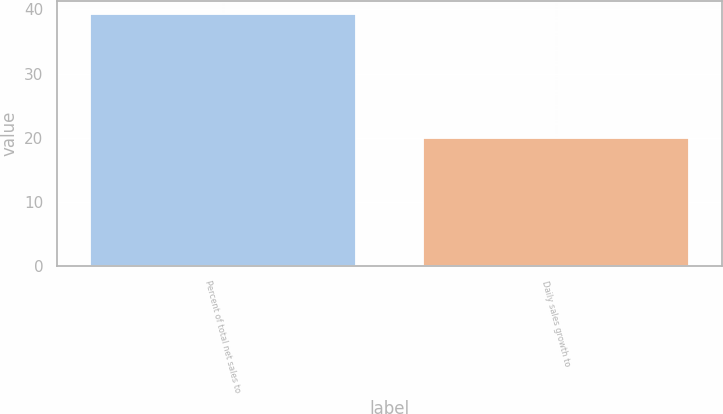Convert chart. <chart><loc_0><loc_0><loc_500><loc_500><bar_chart><fcel>Percent of total net sales to<fcel>Daily sales growth to<nl><fcel>39.3<fcel>20<nl></chart> 